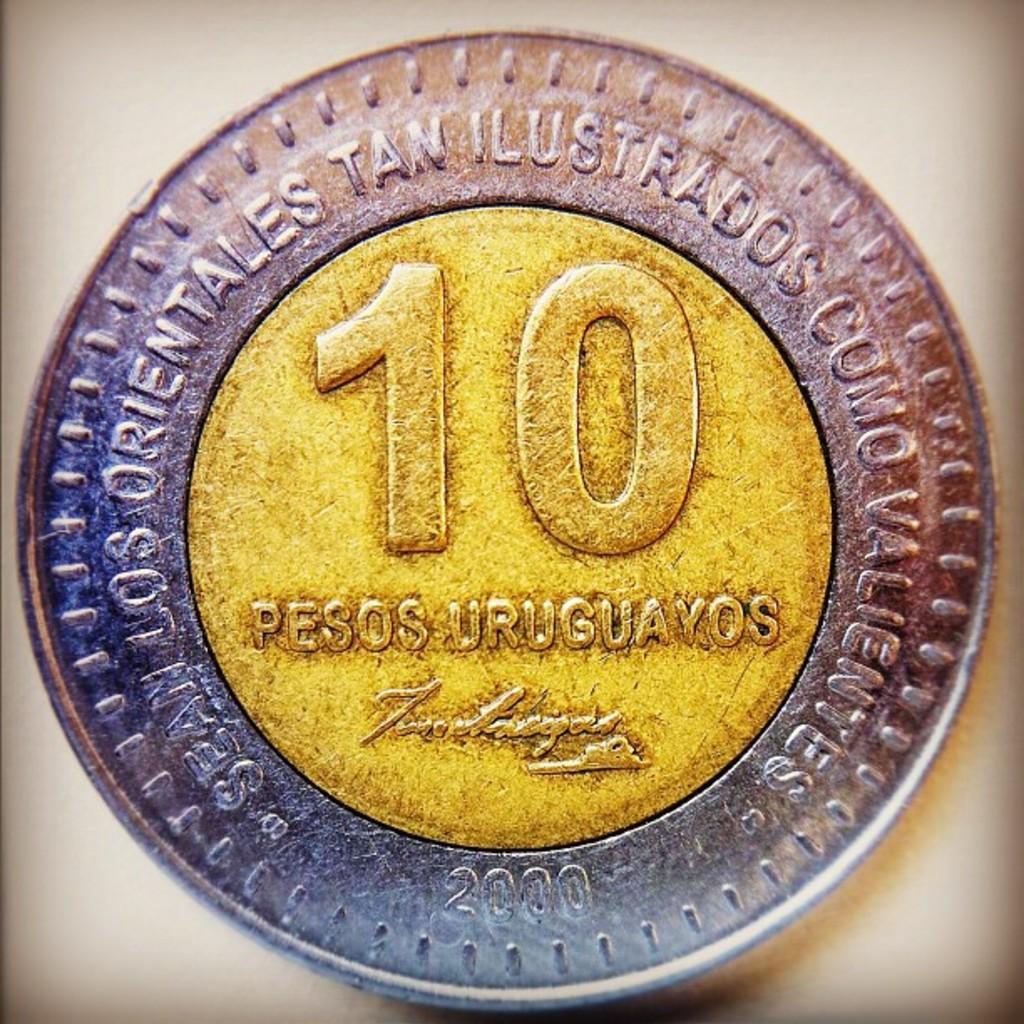What number can be seen on the face of this coin?
Provide a succinct answer. 10. 